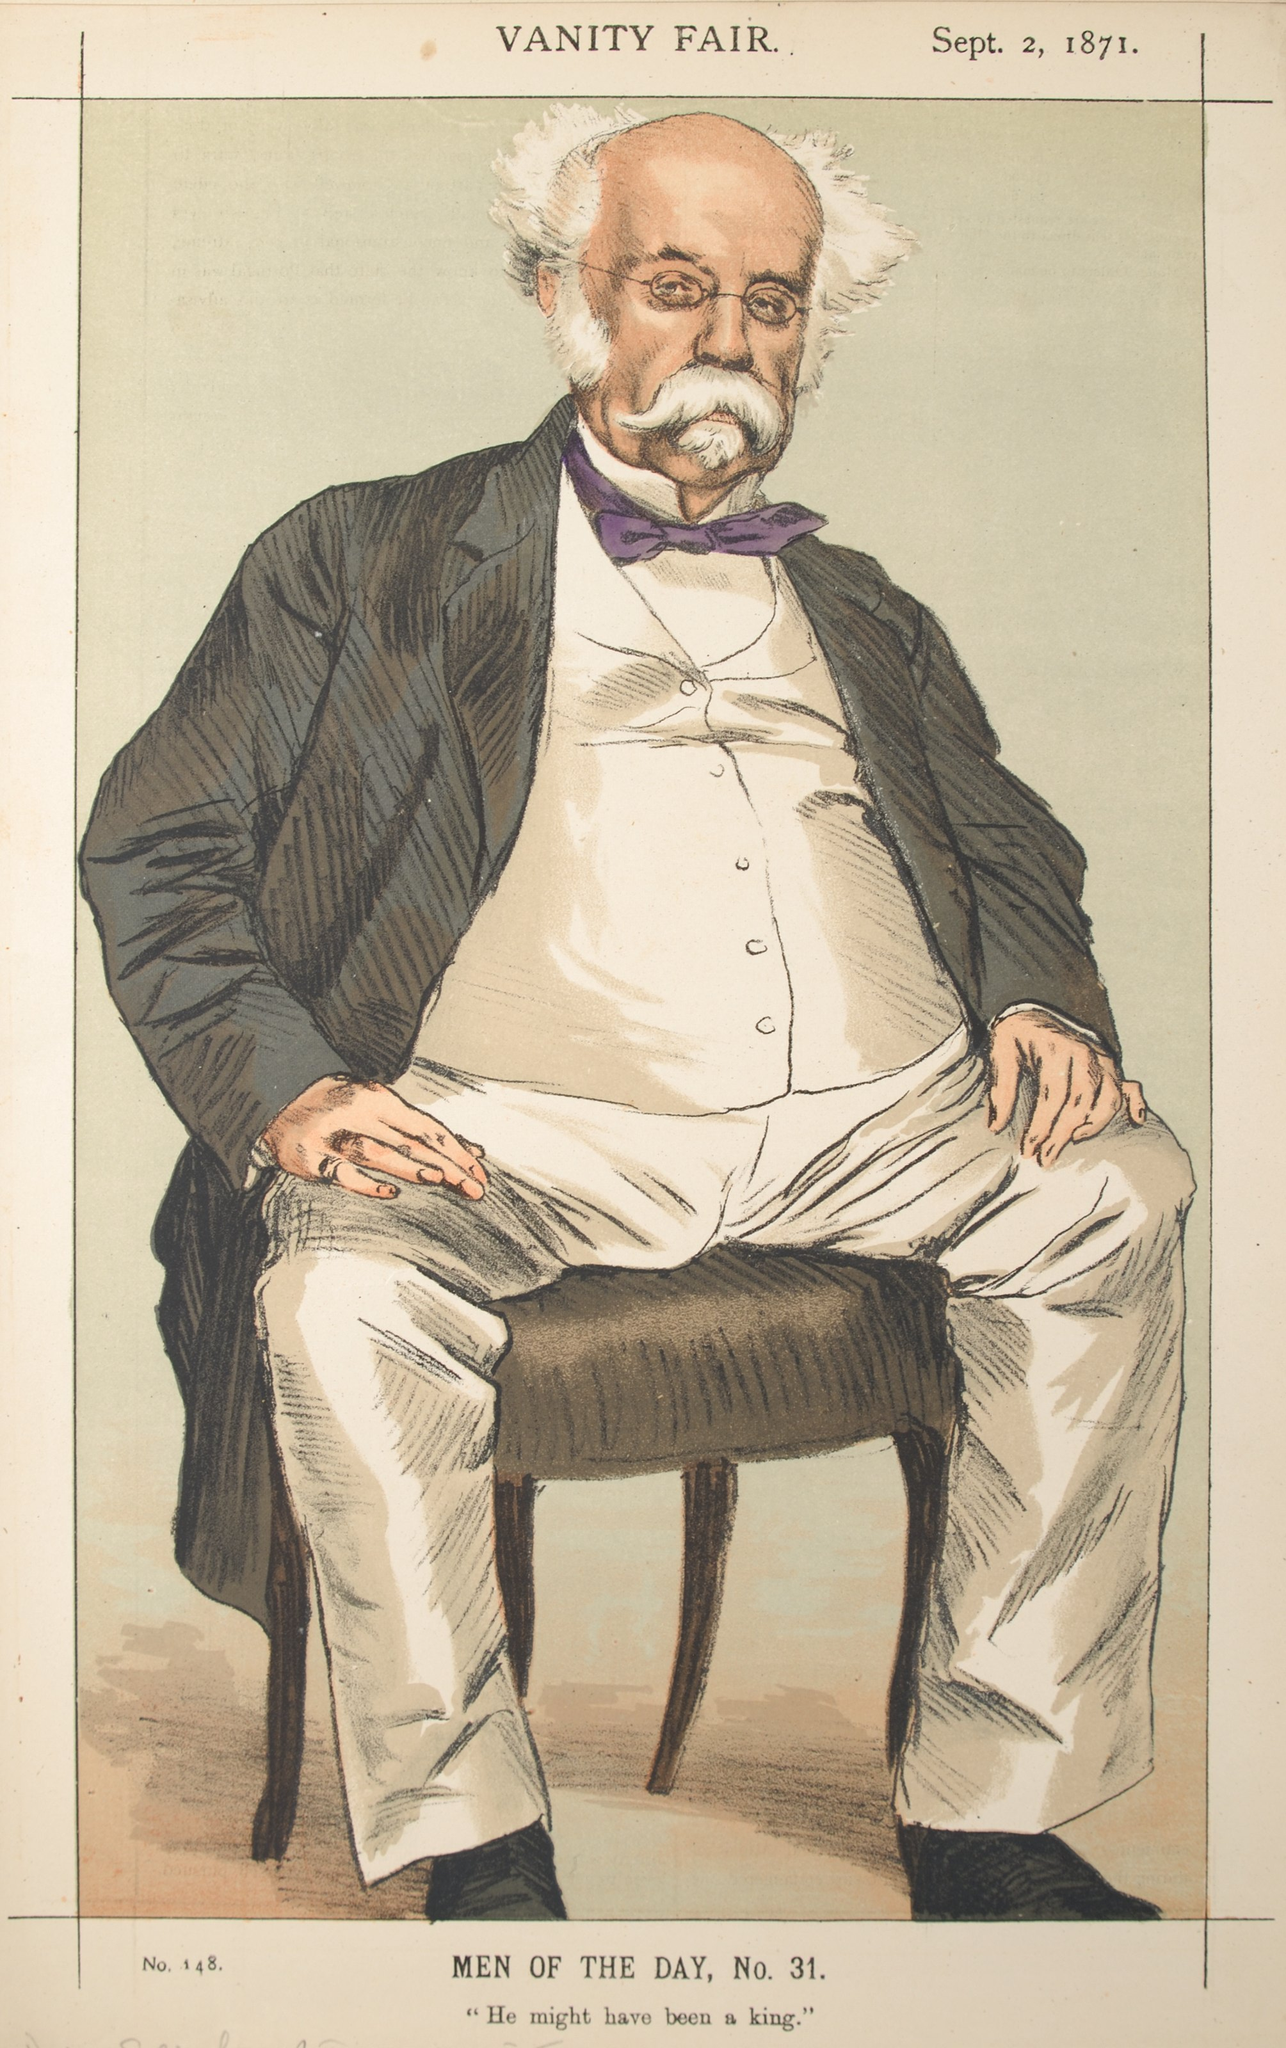Create an incredibly detailed, fantastical scenario involving the man in the caricature. The image brings to life Sir Percival Whimsybottom, the Grand Chancellor of Aetherian Sciences in the floating city of Skytropolis, a dazzling metropolis suspended among the clouds, powered by the rare and powerful Aetherium crystals. Sir Percival, an endearing figure with a fluffy, snow-white beard and a receding hairline, is known for his distinctive choice of attire—a perfectly tailored black suit with a crisp white shirt and a flamboyant purple bowtie, symbolizing his quirky yet brilliant mind.

In this fantastical world, Sir Percival is seated in his grand office, ensconced within a towering citadel adorned with gears and clockwork mechanisms, gently humming to the rhythm of the city's heartbeat. His office is a marvel to behold: ancient tomes line the walls, filled with knowledge of the arcane and scientific; intricate blueprints of imaginative inventions lie strewn across his mahogany desk, illuminated by the warm, ambient glow of luminescent gas lamps.

As the Grand Chancellor, Sir Percival is working on his magnum opus—a groundbreaking device that could harness the city's own energy to create a perpetual power source. This ingenious invention, the Aetherial Dynamo, is a complex array of gears, pistons, and humming crystals. It has the potential to resolve Skytropolis's energy crises once and for all, creating an era of unimaginable prosperity. However, there is a twist: Sir Percival's rival, the nefarious Lord Arcanum, plots in the shadows, intending to sabotage the Dynamo and claim the glory for himself.

With the fate of Skytropolis hanging in the balance, Sir Percival must summon all his wit and courage. Aided by his loyal apprentice, Lady Eloise Gearheart, and a ragtag group of misfit inventors, they embark on a thrilling race against time. Their journey takes them through the dazzling Cloud Markets, past the towering Aetherium Mines, and into the heart of the secretive Underbelly, where hidden perils await. Along the way, they encounter sky pirates, mechanical beasts, and ancient guardians, adding layers of complexity and mythos to their quest.

As the day of reckoning approaches, Sir Percival stands resolute, his eyes gleaming with determination behind his spectacles. The climax of their adventure unfolds in a whirlwind of steam and magic, where the true strength of their bonds and ingenuity are tested. Sir Percival's indomitable spirit and keen intellect illuminate the way, holding the promise of saving Skytropolis and cementing his legacy as a hero of the ages. 